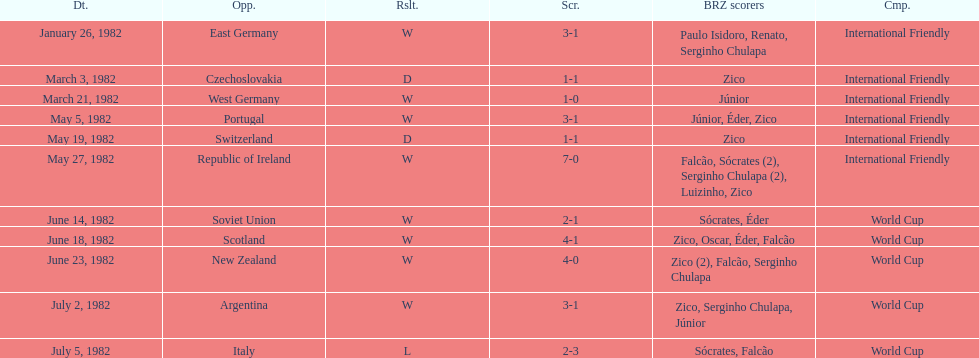Who won on january 26, 1982 and may 27, 1982? Brazil. 